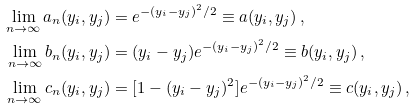Convert formula to latex. <formula><loc_0><loc_0><loc_500><loc_500>\lim _ { n \to \infty } a _ { n } ( y _ { i } , y _ { j } ) & = e ^ { - ( y _ { i } - y _ { j } ) ^ { 2 } / 2 } \equiv a ( y _ { i } , y _ { j } ) \, , \\ \lim _ { n \to \infty } b _ { n } ( y _ { i } , y _ { j } ) & = ( y _ { i } - y _ { j } ) e ^ { - ( y _ { i } - y _ { j } ) ^ { 2 } / 2 } \equiv b ( y _ { i } , y _ { j } ) \, , \\ \lim _ { n \to \infty } c _ { n } ( y _ { i } , y _ { j } ) & = [ 1 - ( y _ { i } - y _ { j } ) ^ { 2 } ] e ^ { - ( y _ { i } - y _ { j } ) ^ { 2 } / 2 } \equiv c ( y _ { i } , y _ { j } ) \, , \\</formula> 